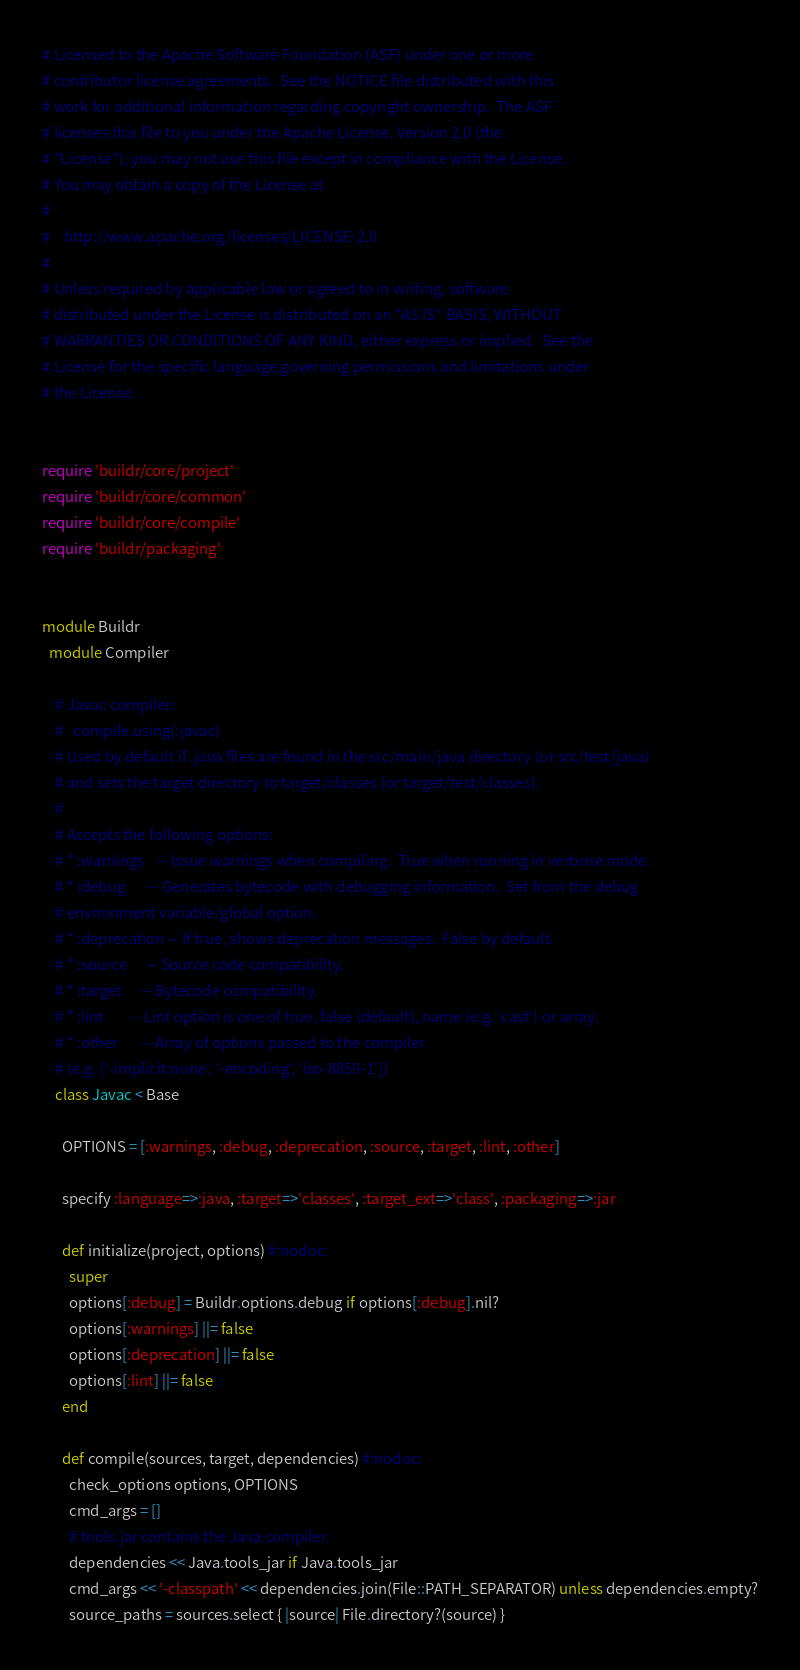Convert code to text. <code><loc_0><loc_0><loc_500><loc_500><_Ruby_># Licensed to the Apache Software Foundation (ASF) under one or more
# contributor license agreements.  See the NOTICE file distributed with this
# work for additional information regarding copyright ownership.  The ASF
# licenses this file to you under the Apache License, Version 2.0 (the
# "License"); you may not use this file except in compliance with the License.
# You may obtain a copy of the License at
#
#    http://www.apache.org/licenses/LICENSE-2.0
#
# Unless required by applicable law or agreed to in writing, software
# distributed under the License is distributed on an "AS IS" BASIS, WITHOUT
# WARRANTIES OR CONDITIONS OF ANY KIND, either express or implied.  See the
# License for the specific language governing permissions and limitations under
# the License.


require 'buildr/core/project'
require 'buildr/core/common'
require 'buildr/core/compile'
require 'buildr/packaging'


module Buildr
  module Compiler

    # Javac compiler:
    #   compile.using(:javac)
    # Used by default if .java files are found in the src/main/java directory (or src/test/java)
    # and sets the target directory to target/classes (or target/test/classes).
    #
    # Accepts the following options:
    # * :warnings    -- Issue warnings when compiling.  True when running in verbose mode.
    # * :debug       -- Generates bytecode with debugging information.  Set from the debug
    # environment variable/global option.
    # * :deprecation -- If true, shows deprecation messages.  False by default.
    # * :source      -- Source code compatibility.
    # * :target      -- Bytecode compatibility.
    # * :lint        -- Lint option is one of true, false (default), name (e.g. 'cast') or array.
    # * :other       -- Array of options passed to the compiler
    # (e.g. ['-implicit:none', '-encoding', 'iso-8859-1'])
    class Javac < Base

      OPTIONS = [:warnings, :debug, :deprecation, :source, :target, :lint, :other]

      specify :language=>:java, :target=>'classes', :target_ext=>'class', :packaging=>:jar

      def initialize(project, options) #:nodoc:
        super
        options[:debug] = Buildr.options.debug if options[:debug].nil?
        options[:warnings] ||= false
        options[:deprecation] ||= false
        options[:lint] ||= false
      end

      def compile(sources, target, dependencies) #:nodoc:
        check_options options, OPTIONS
        cmd_args = []
        # tools.jar contains the Java compiler.
        dependencies << Java.tools_jar if Java.tools_jar
        cmd_args << '-classpath' << dependencies.join(File::PATH_SEPARATOR) unless dependencies.empty?
        source_paths = sources.select { |source| File.directory?(source) }</code> 